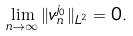<formula> <loc_0><loc_0><loc_500><loc_500>\lim _ { n \rightarrow \infty } \| v ^ { j _ { 0 } } _ { n } \| _ { L ^ { 2 } } = 0 .</formula> 